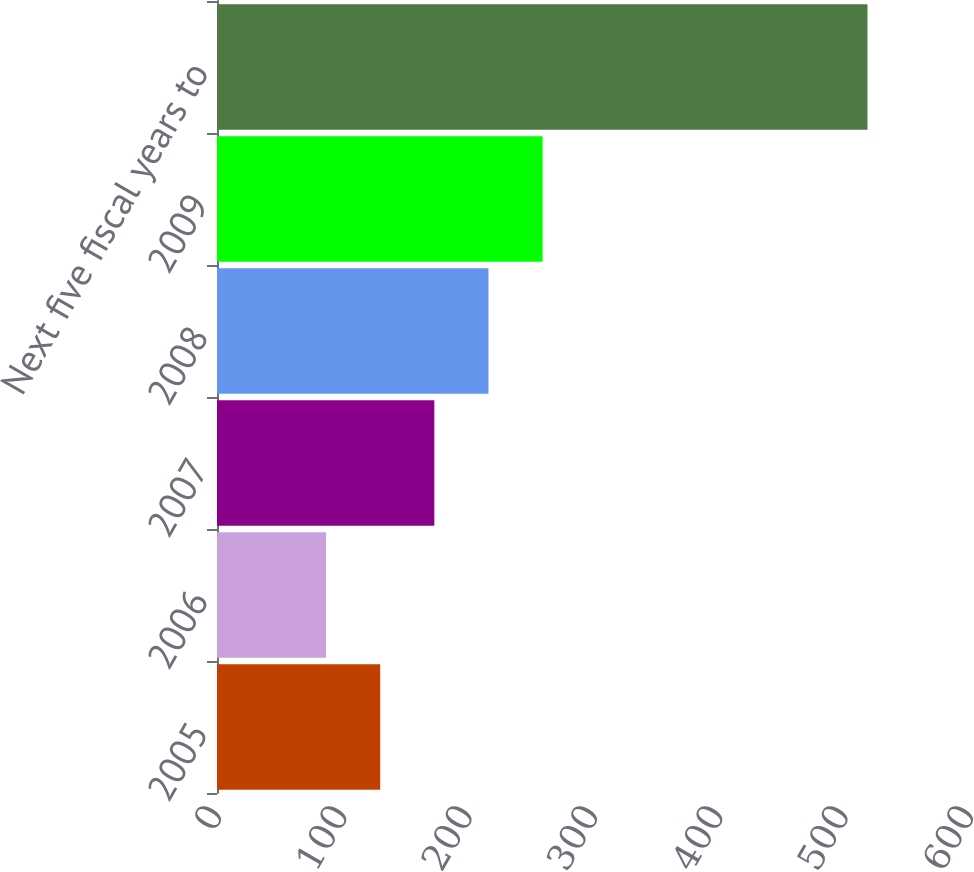Convert chart to OTSL. <chart><loc_0><loc_0><loc_500><loc_500><bar_chart><fcel>2005<fcel>2006<fcel>2007<fcel>2008<fcel>2009<fcel>Next five fiscal years to<nl><fcel>130.2<fcel>87<fcel>173.4<fcel>216.6<fcel>259.8<fcel>519<nl></chart> 